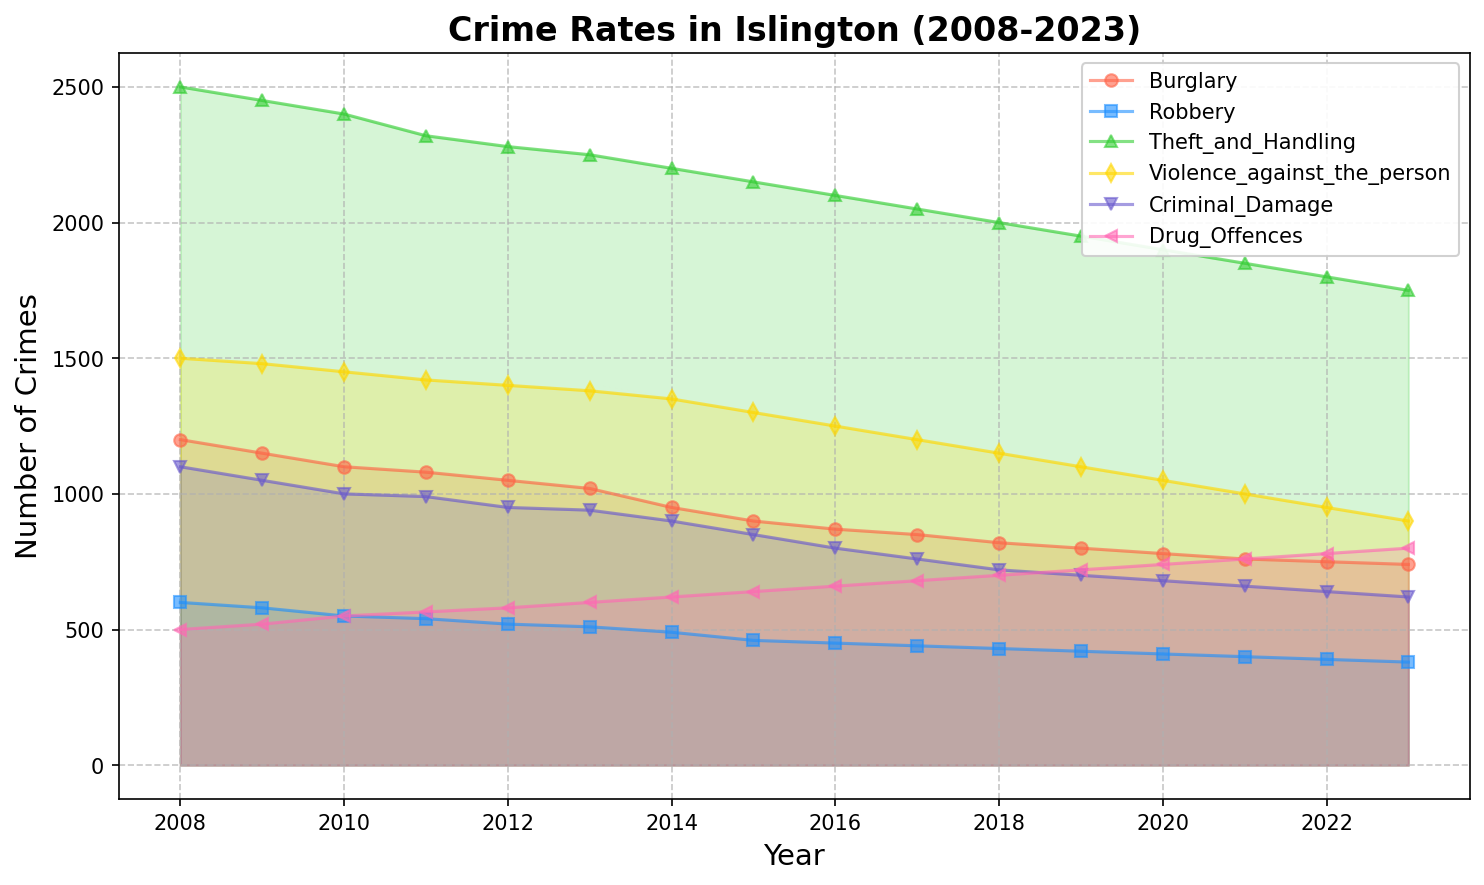Which crime type had the highest number of crimes committed in 2008? Observe the heights of the curves for the year 2008 and the labels for each crime type. The curve representing "Theft_and_Handling" is the highest in 2008.
Answer: Theft_and_Handling What is the total number of Drug Offences over the past 15 years? Sum the values for Drug_Offences from 2008 to 2023. This involves summing each year: 500 + 520 + 550 + 565 + 580 + 600 + 620 + 640 + 660 + 680 + 700 + 720 + 740 + 760 + 780 + 800 = 10695
Answer: 10695 Which year saw the sharpest decrease in Burglary cases? Compare the differences in Burglary cases year over year. The sharpest decrease is from 2013 to 2014, where cases went from 1020 to 950, a decrease of 70.
Answer: 2013 to 2014 How many more Criminal Damage cases were there in 2008 compared to 2023? Subtract the number of Criminal Damage cases in 2023 from those in 2008. Therefore, 1100 (2008) - 620 (2023) = 480.
Answer: 480 What was the average number of Robbery cases over the years 2011-2015? Sum the number of Robbery cases from 2011 to 2015 and divide by 5. The sum is 540 + 520 + 510 + 490 + 460 = 2520, so the average is 2520 / 5 = 504
Answer: 504 Which crime type has consistently decreased over the last 15 years? Observe the general trend for each crime type from 2008 to 2023. All crime types show a decreasing trend, but "Violence_agains_the_person" consistently decreased each year.
Answer: Violence_against_the_person In which year did Violence against the person fall below 1000 cases? Check the "Violence_against_the_person" line to find the first year it dips below 1000 cases. It first falls below in 2021, with 1000 cases.
Answer: 2021 Which crime type has shown an increasing trend over the past 15 years? None of the types shown an increasing trend
Answer: None By how many units did Theft_and_Handling decrease from 2008 to 2023? Subtract the number of Theft_and_Handling cases in 2023 from those in 2008. Therefore, 2500 (2008) - 1750 (2023) = 750.
Answer: 750 